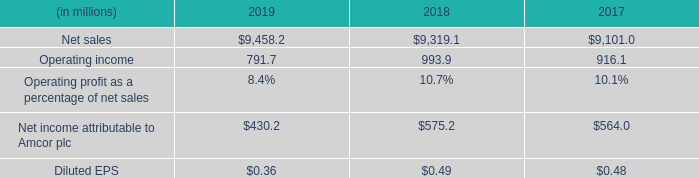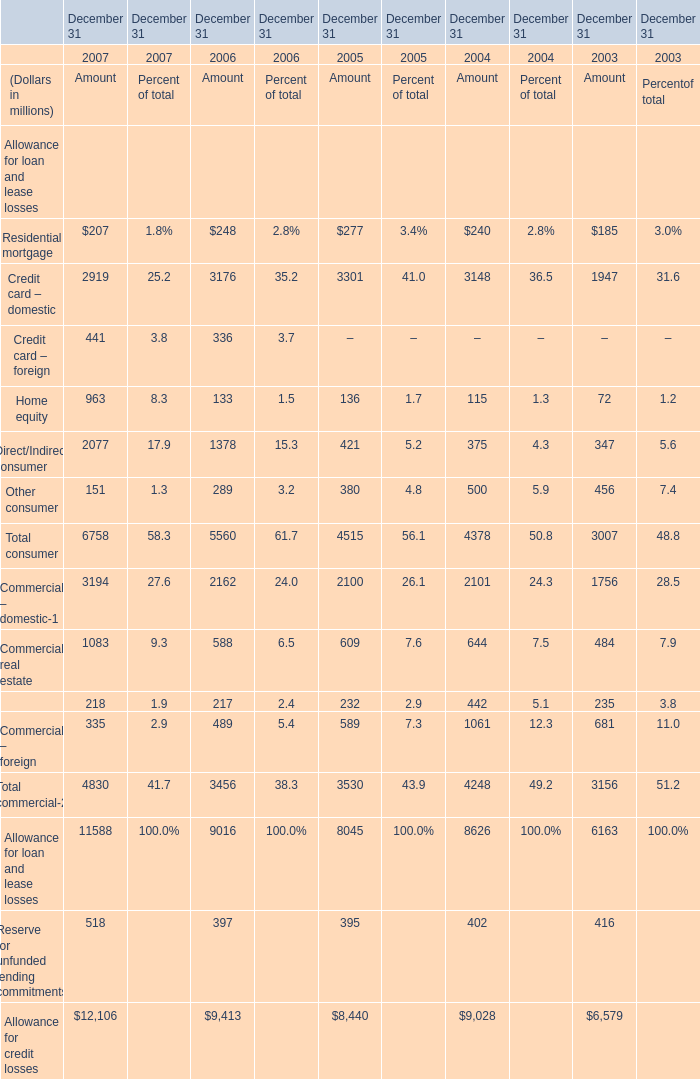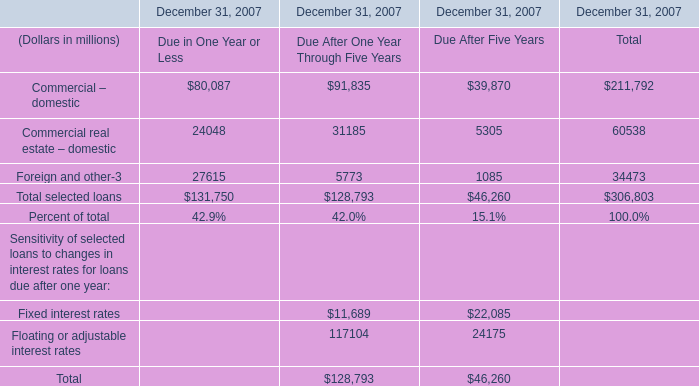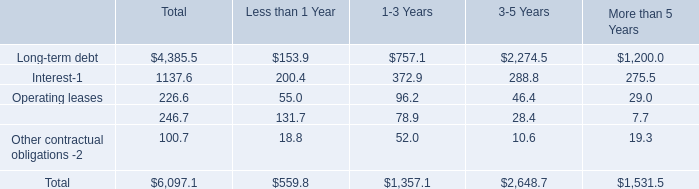What is the growing rate of Credit card – domestic in the year with the most Residential mortgage? 
Computations: ((3301 - 3148) / 3148)
Answer: 0.0486. 